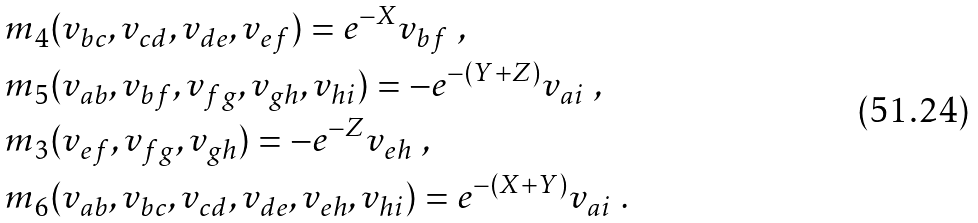Convert formula to latex. <formula><loc_0><loc_0><loc_500><loc_500>& m _ { 4 } ( v _ { b c } , v _ { c d } , v _ { d e } , v _ { e f } ) = e ^ { - X } v _ { b f } \ , \\ & m _ { 5 } ( v _ { a b } , v _ { b f } , v _ { f g } , v _ { g h } , v _ { h i } ) = - e ^ { - ( Y + Z ) } v _ { a i } \ , \\ & m _ { 3 } ( v _ { e f } , v _ { f g } , v _ { g h } ) = - e ^ { - Z } v _ { e h } \ , \\ & m _ { 6 } ( v _ { a b } , v _ { b c } , v _ { c d } , v _ { d e } , v _ { e h } , v _ { h i } ) = e ^ { - ( X + Y ) } v _ { a i } \ .</formula> 